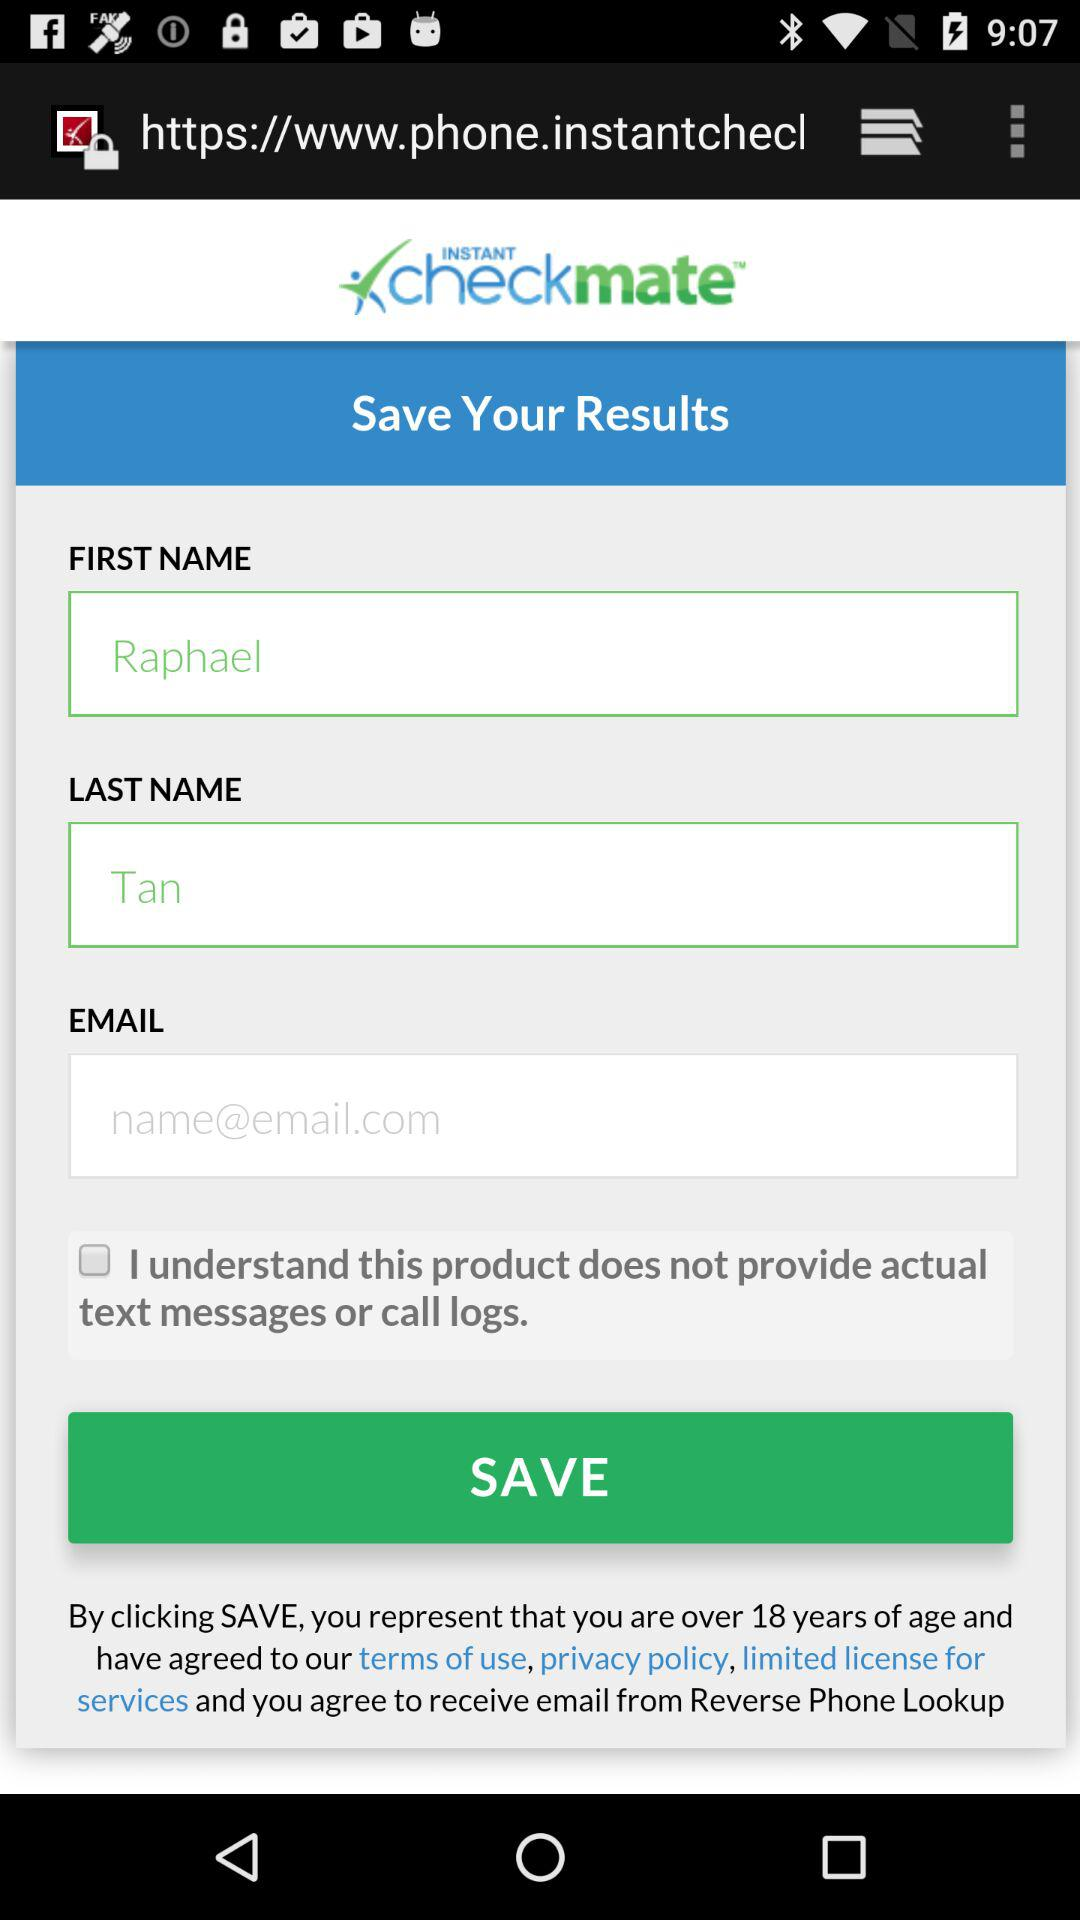How many text inputs are there that are not first name?
Answer the question using a single word or phrase. 2 